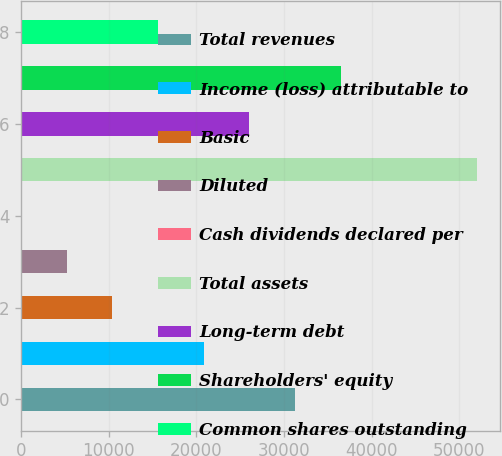<chart> <loc_0><loc_0><loc_500><loc_500><bar_chart><fcel>Total revenues<fcel>Income (loss) attributable to<fcel>Basic<fcel>Diluted<fcel>Cash dividends declared per<fcel>Total assets<fcel>Long-term debt<fcel>Shareholders' equity<fcel>Common shares outstanding<nl><fcel>31230.8<fcel>20820.8<fcel>10410.7<fcel>5205.64<fcel>0.6<fcel>52051<fcel>26025.8<fcel>36435.9<fcel>15615.7<nl></chart> 